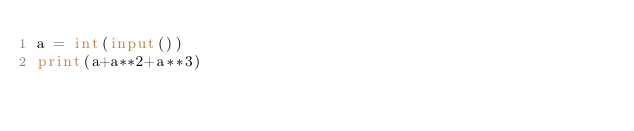Convert code to text. <code><loc_0><loc_0><loc_500><loc_500><_Python_>a = int(input())
print(a+a**2+a**3)</code> 